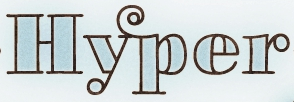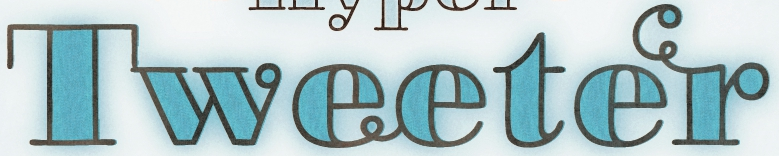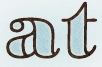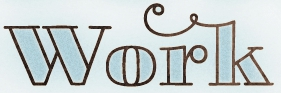Read the text content from these images in order, separated by a semicolon. Hyper; Tweeter; at; work 